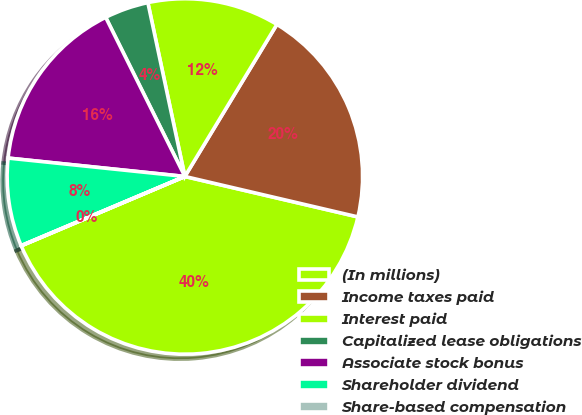Convert chart. <chart><loc_0><loc_0><loc_500><loc_500><pie_chart><fcel>(In millions)<fcel>Income taxes paid<fcel>Interest paid<fcel>Capitalized lease obligations<fcel>Associate stock bonus<fcel>Shareholder dividend<fcel>Share-based compensation<nl><fcel>39.96%<fcel>19.99%<fcel>12.0%<fcel>4.01%<fcel>16.0%<fcel>8.01%<fcel>0.02%<nl></chart> 